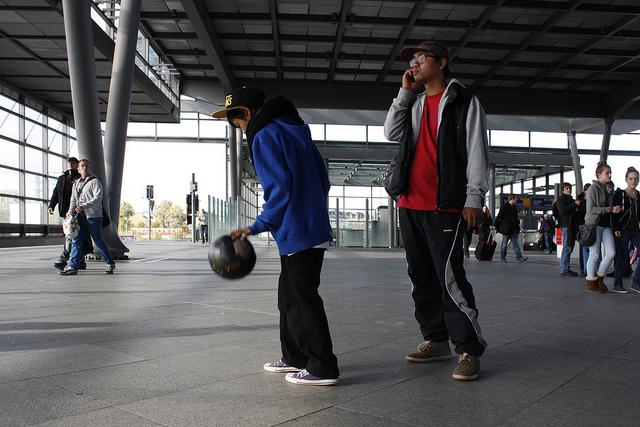What is the boy doing with the black ball?

Choices:
A) dribbling
B) passing
C) throwing
D) polishing dribbling 